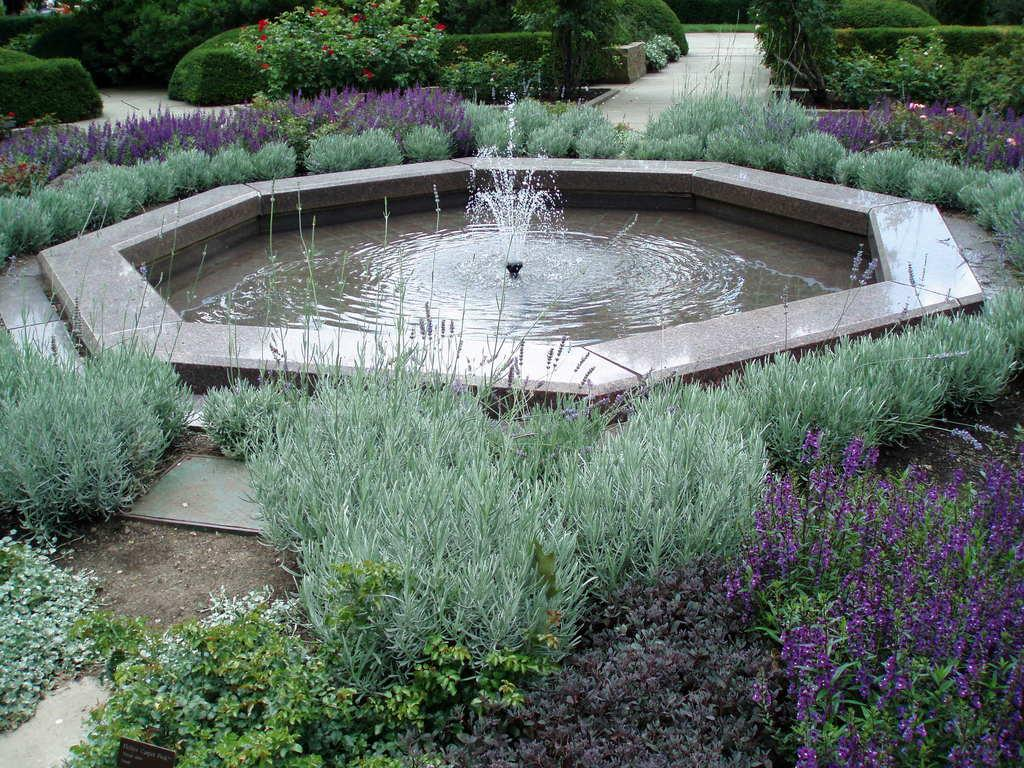What type of vegetation can be seen in the image? There are flowers, plants, and shrubs in the image. What additional feature is present in the image? There is a water fountain in the image. What is the profit generated by the bottle in the image? There is no bottle present in the image, so it is not possible to determine any profit generated. 